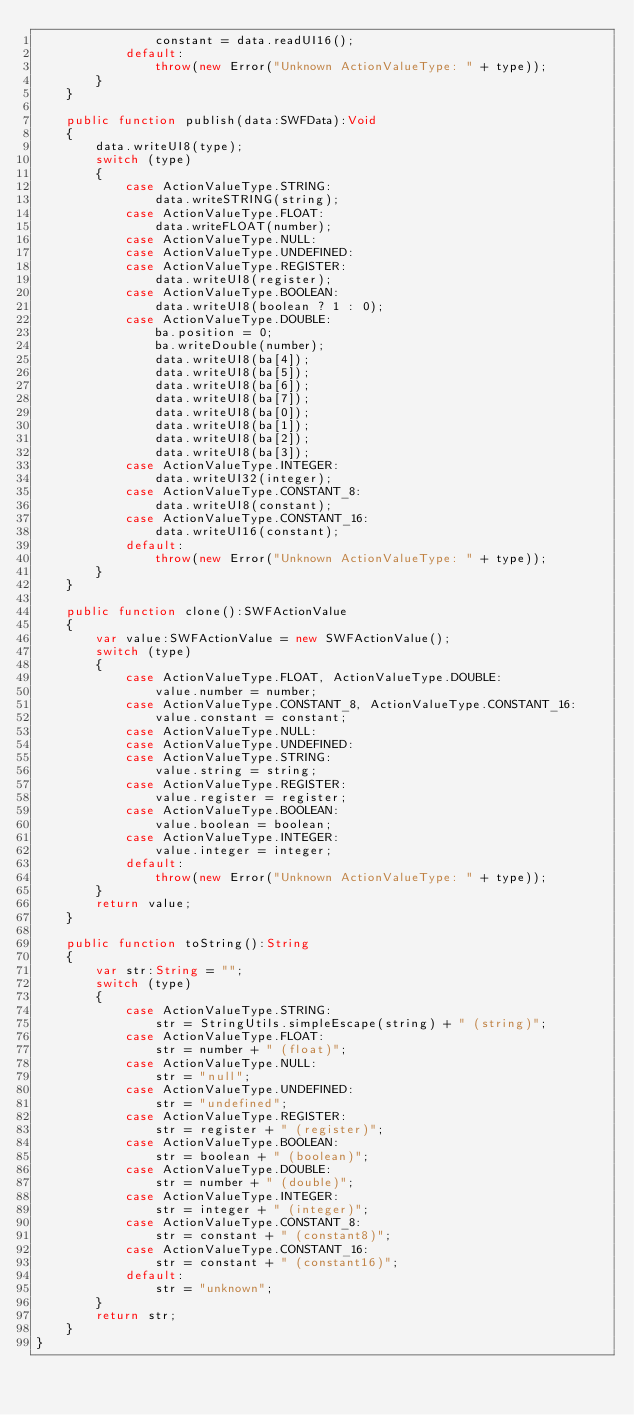<code> <loc_0><loc_0><loc_500><loc_500><_Haxe_>				constant = data.readUI16();
			default:
				throw(new Error("Unknown ActionValueType: " + type));
		}
	}

	public function publish(data:SWFData):Void
	{
		data.writeUI8(type);
		switch (type)
		{
			case ActionValueType.STRING:
				data.writeSTRING(string);
			case ActionValueType.FLOAT:
				data.writeFLOAT(number);
			case ActionValueType.NULL:
			case ActionValueType.UNDEFINED:
			case ActionValueType.REGISTER:
				data.writeUI8(register);
			case ActionValueType.BOOLEAN:
				data.writeUI8(boolean ? 1 : 0);
			case ActionValueType.DOUBLE:
				ba.position = 0;
				ba.writeDouble(number);
				data.writeUI8(ba[4]);
				data.writeUI8(ba[5]);
				data.writeUI8(ba[6]);
				data.writeUI8(ba[7]);
				data.writeUI8(ba[0]);
				data.writeUI8(ba[1]);
				data.writeUI8(ba[2]);
				data.writeUI8(ba[3]);
			case ActionValueType.INTEGER:
				data.writeUI32(integer);
			case ActionValueType.CONSTANT_8:
				data.writeUI8(constant);
			case ActionValueType.CONSTANT_16:
				data.writeUI16(constant);
			default:
				throw(new Error("Unknown ActionValueType: " + type));
		}
	}

	public function clone():SWFActionValue
	{
		var value:SWFActionValue = new SWFActionValue();
		switch (type)
		{
			case ActionValueType.FLOAT, ActionValueType.DOUBLE:
				value.number = number;
			case ActionValueType.CONSTANT_8, ActionValueType.CONSTANT_16:
				value.constant = constant;
			case ActionValueType.NULL:
			case ActionValueType.UNDEFINED:
			case ActionValueType.STRING:
				value.string = string;
			case ActionValueType.REGISTER:
				value.register = register;
			case ActionValueType.BOOLEAN:
				value.boolean = boolean;
			case ActionValueType.INTEGER:
				value.integer = integer;
			default:
				throw(new Error("Unknown ActionValueType: " + type));
		}
		return value;
	}

	public function toString():String
	{
		var str:String = "";
		switch (type)
		{
			case ActionValueType.STRING:
				str = StringUtils.simpleEscape(string) + " (string)";
			case ActionValueType.FLOAT:
				str = number + " (float)";
			case ActionValueType.NULL:
				str = "null";
			case ActionValueType.UNDEFINED:
				str = "undefined";
			case ActionValueType.REGISTER:
				str = register + " (register)";
			case ActionValueType.BOOLEAN:
				str = boolean + " (boolean)";
			case ActionValueType.DOUBLE:
				str = number + " (double)";
			case ActionValueType.INTEGER:
				str = integer + " (integer)";
			case ActionValueType.CONSTANT_8:
				str = constant + " (constant8)";
			case ActionValueType.CONSTANT_16:
				str = constant + " (constant16)";
			default:
				str = "unknown";
		}
		return str;
	}
}
</code> 